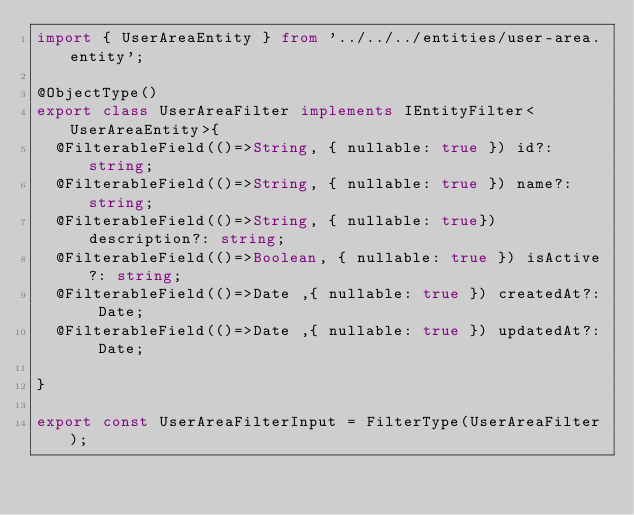Convert code to text. <code><loc_0><loc_0><loc_500><loc_500><_TypeScript_>import { UserAreaEntity } from '../../../entities/user-area.entity';

@ObjectType()
export class UserAreaFilter implements IEntityFilter<UserAreaEntity>{
  @FilterableField(()=>String, { nullable: true }) id?: string;
  @FilterableField(()=>String, { nullable: true }) name?: string;
  @FilterableField(()=>String, { nullable: true}) description?: string;
  @FilterableField(()=>Boolean, { nullable: true }) isActive?: string;
  @FilterableField(()=>Date ,{ nullable: true }) createdAt?: Date;
  @FilterableField(()=>Date ,{ nullable: true }) updatedAt?: Date;

}

export const UserAreaFilterInput = FilterType(UserAreaFilter);</code> 